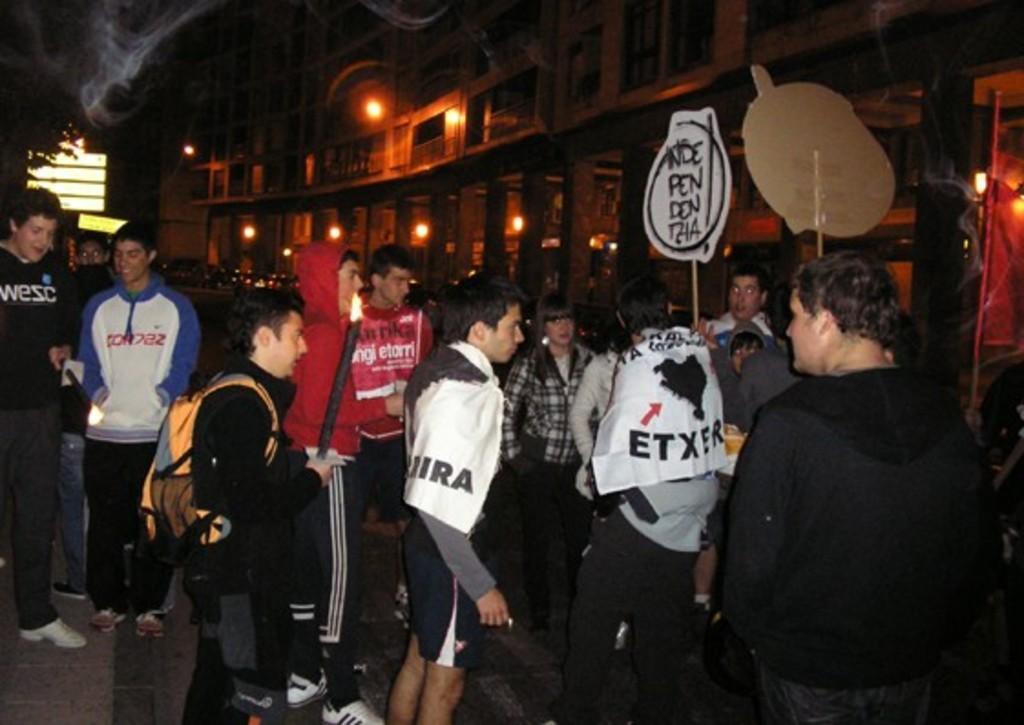Could you give a brief overview of what you see in this image? Here we can see people. These two people are holding boards and another two people are holding fire objects. Background we can see buildings, lights and tree. 